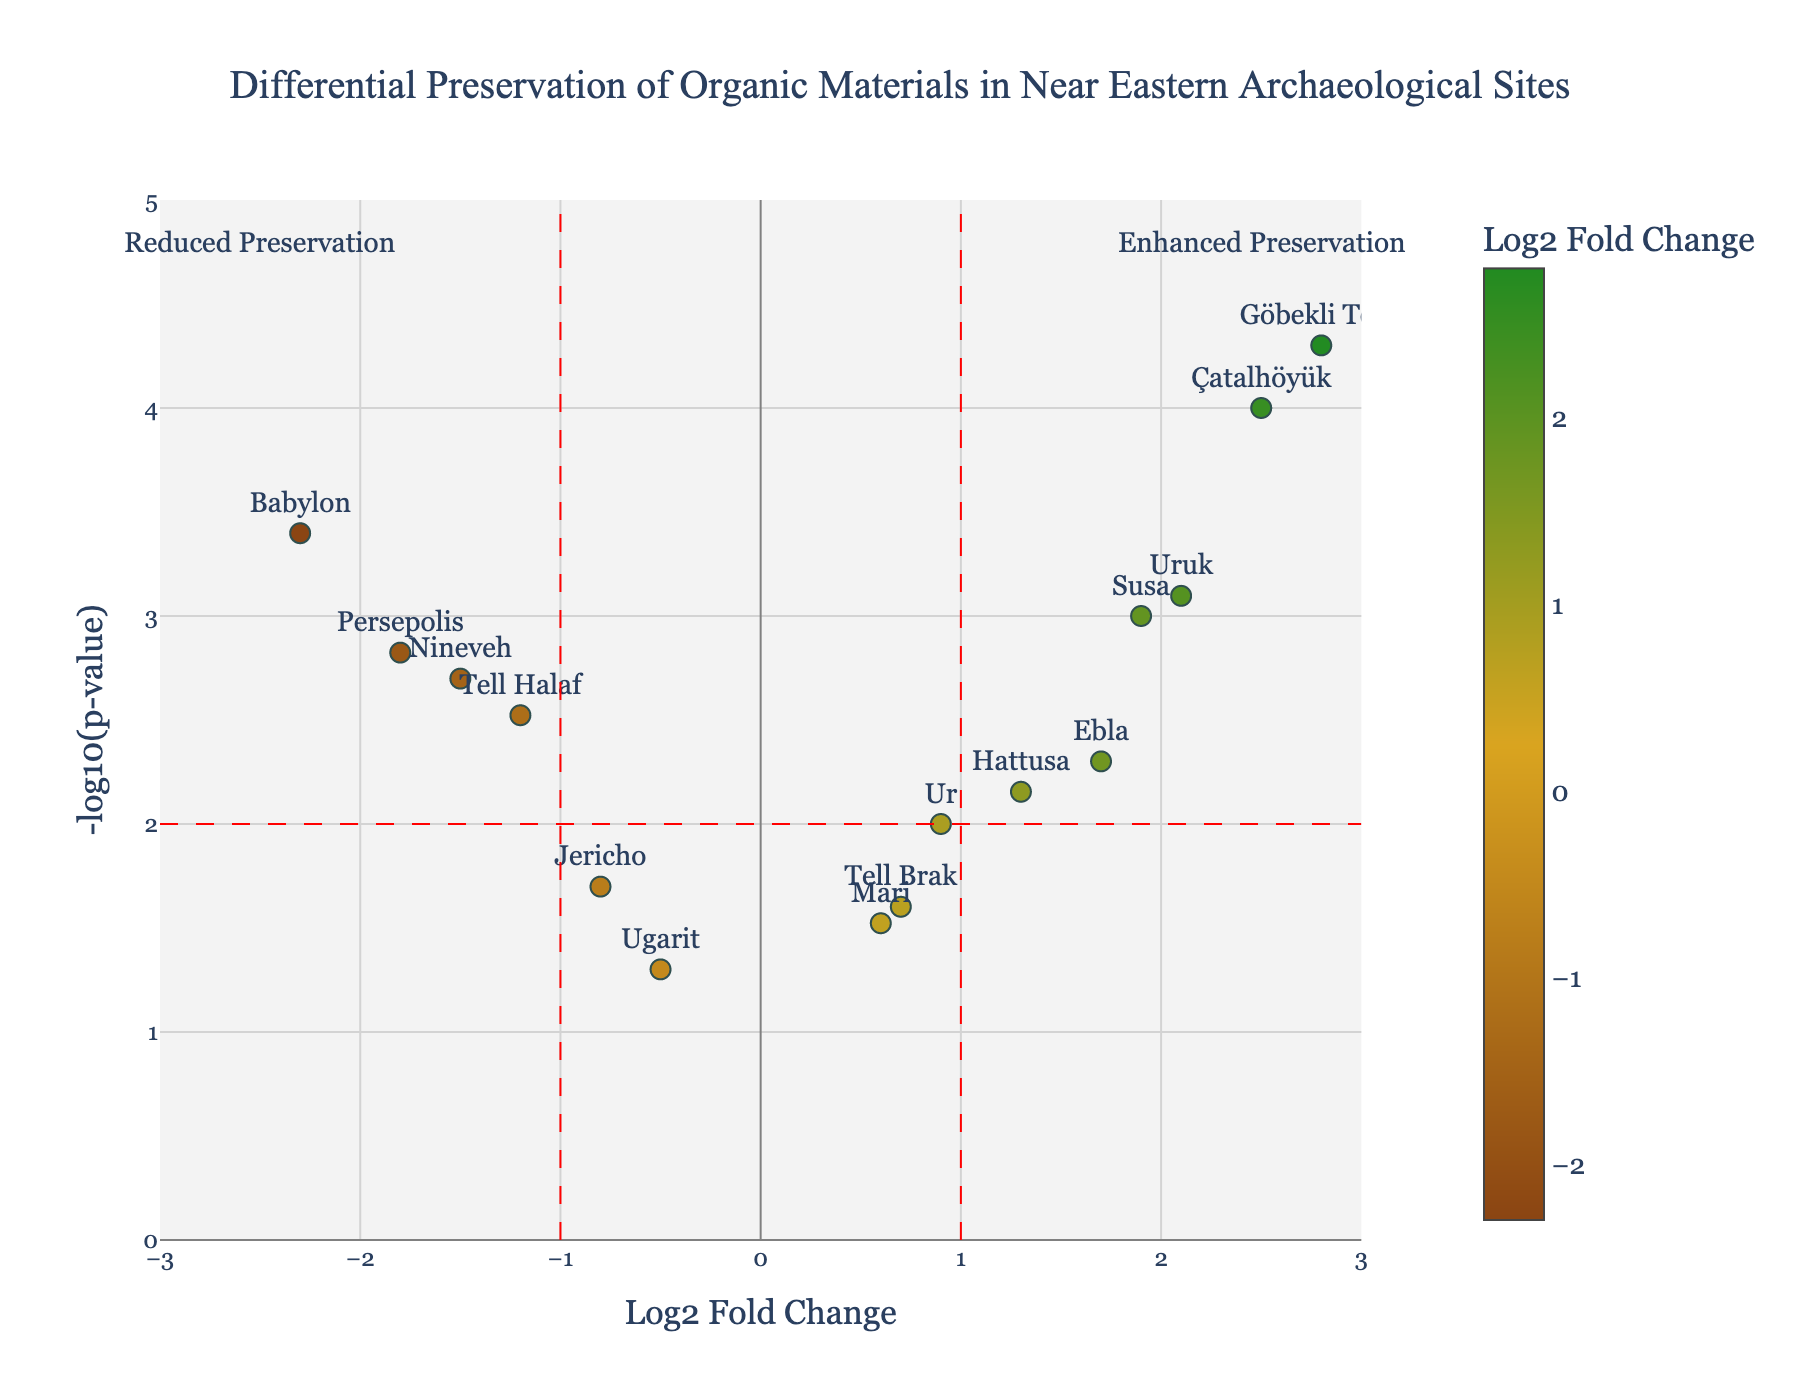What is the title of the figure? The title is usually located at the top of the figure and provides a brief description of the content. Here, it reads "Differential Preservation of Organic Materials in Near Eastern Archaeological Sites."
Answer: Differential Preservation of Organic Materials in Near Eastern Archaeological Sites How many data points are shown in the plot? Each archaeological site is represented by a data point in the plot. There are 15 sites listed in the data table, corresponding to 15 data points.
Answer: 15 Which site has the highest -log10(p-value)? The highest -log10(p-value) represents the most significant p-value. Göbekli Tepe, with a -log10(p-value) plotted near 5, has the highest value.
Answer: Göbekli Tepe What does a positive Log2 Fold Change (LogFC) indicate in the context of this plot? A positive LogFC indicates enhanced preservation of organic materials compared to a baseline. The color scale and annotations on the plot also suggest this.
Answer: Enhanced preservation Which two sites indicate the greatest differential preservation, one with enhanced and one with reduced preservation? To identify these, look for the maximum positive and negative LogFC values. Göbekli Tepe has the highest positive LogFC (~2.8), and Babylon has the lowest negative LogFC (~-2.3).
Answer: Göbekli Tepe (enhanced) and Babylon (reduced) Which sites fall outside the thresholds of LogFC ±1 and -log10(p-value) 2? Sites falling outside these thresholds have LogFC values greater than 1 or less than -1 and -log10(p-values) greater than 2. These sites include Babylon, Nineveh, Tell Halaf, Perspeolis, Çatalhöyük, Göbekli Tepe, Uruk, Ebla, and Susa.
Answer: Babylon, Nineveh, Tell Halaf, Perspeolis, Çatalhöyük, Göbekli Tepe, Uruk, Ebla, Susa How is the point for Nineveh characterized in terms of LogFC and p-value? The point for Nineveh has a LogFC of around -1.5 and a p-value which converts to approximately 2.7 in -log10(p-value), signifying reduced preservation with high significance. The visual elements corroborate these values.
Answer: LogFC: -1.5, p-value: 0.002 Which site has the least significant p-value, and what is its -log10(p-value)? The least significant p-value is the highest p-value, which corresponds to the lowest -log10(p-value). Ugarit's point is the lowest at -log10(p-value) = 1.3.
Answer: Ugarit, -log10(p-value): 1.3 Among Tell Brak, Ur, and Mari, which has the most significant p-value? Compare the -log10(p-value) for these sites. Tell Brak (~1.6), Ur (~2), and Mari (~1.5). Ur has the highest -log10(p-value) and thus the most significant p-value.
Answer: Ur 